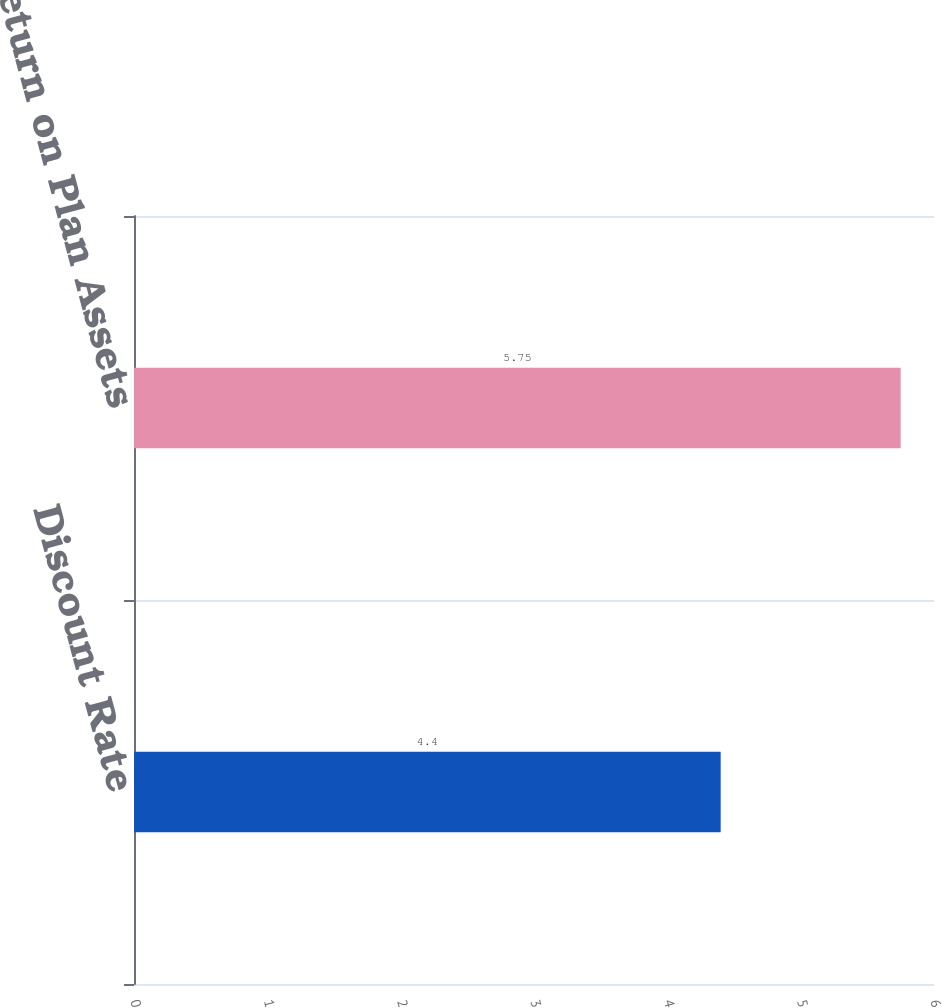Convert chart. <chart><loc_0><loc_0><loc_500><loc_500><bar_chart><fcel>Discount Rate<fcel>Expected Return on Plan Assets<nl><fcel>4.4<fcel>5.75<nl></chart> 